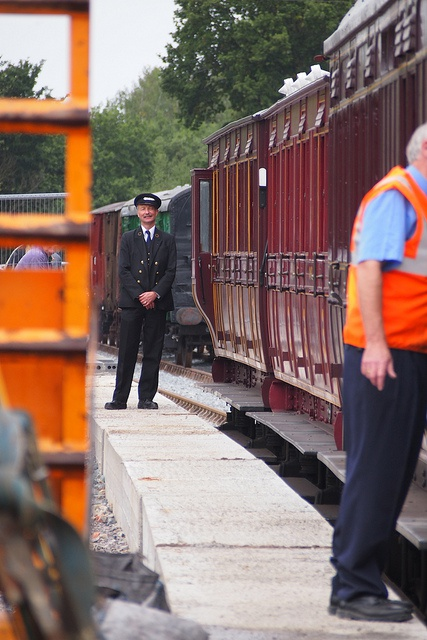Describe the objects in this image and their specific colors. I can see train in brown, maroon, gray, and black tones, people in brown, black, lightpink, and red tones, people in brown, black, and gray tones, train in brown, black, gray, and maroon tones, and people in brown, gray, and violet tones in this image. 